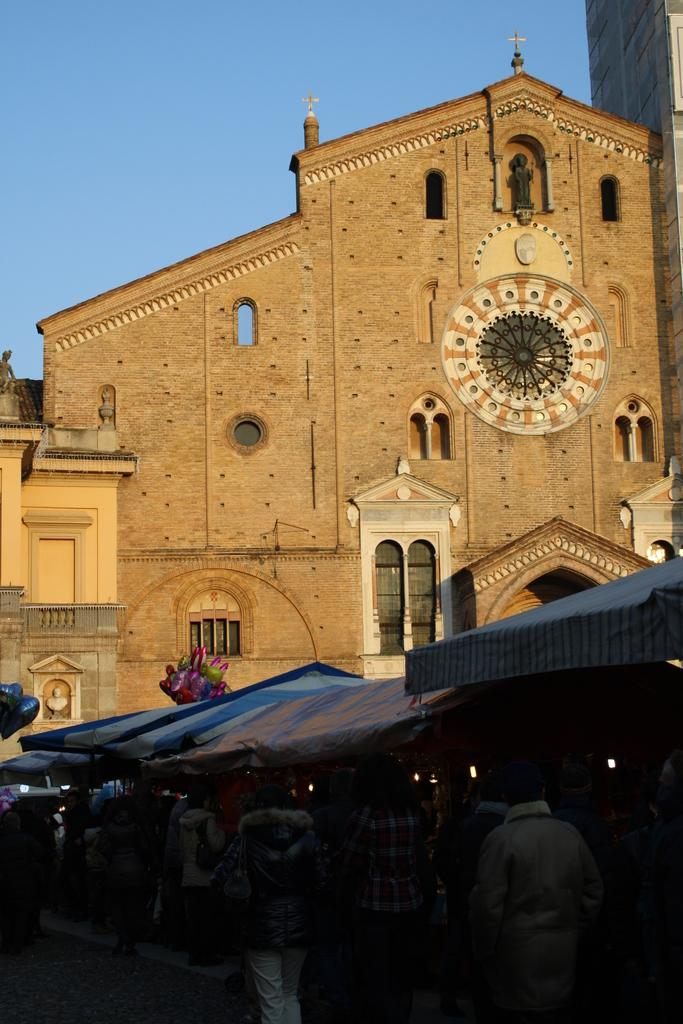What type of structure is visible in the image? There is a building in the image. What feature can be seen on the building? The building has windows. What type of temporary shelter is present on the right side of the image? There are tents on the right side of the image. Who can be seen in the image? There are people standing in the image. What is the condition of the sky in the image? The sky is clear in the image. What type of sign can be seen hanging from the building in the image? There is no sign visible hanging from the building in the image. What type of blade is being used by the people in the image? There is no blade present in the image; the people are not using any tools or instruments. 